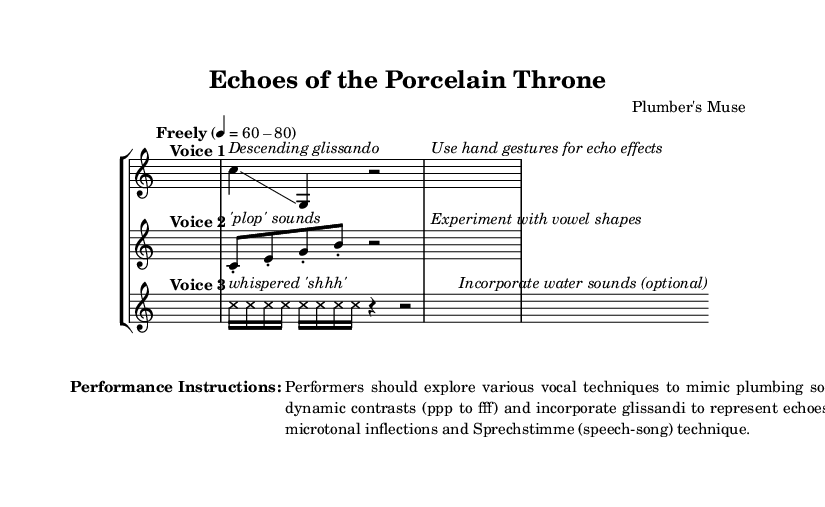What is the time signature of this music? The time signature is found at the beginning of the piece and is indicated as 4/4.
Answer: 4/4 What is the tempo marking for this piece? The tempo marking is noted in the score as "Freely" followed by a range of 60-80 beats per minute.
Answer: 60-80 How many voices are present in this composition? The score clearly labels three distinct voices labeled as "Voice 1", "Voice 2", and "Voice 3".
Answer: Three What vocal techniques are suggested in the performance instructions? The performance instructions mention exploring various vocal techniques, including glissandi, dynamic contrasts, microtonal inflections, and Sprechstimme.
Answer: Various vocal techniques What type of sounds does Voice 2 imitate? The specific sounds that Voice 2 imitates include 'plop' sounds as indicated in the score.
Answer: 'Plop' sounds How does Voice 3 indicate dynamics? Voice 3 indicates dynamics through the use of whispers and varying note lengths, focusing on the whispered 'shhh' and rests to create contrast.
Answer: Whispered 'shhh' What additional sound can be incorporated with Voice 3? The score suggests optionally incorporating water sounds with Voice 3.
Answer: Water sounds 